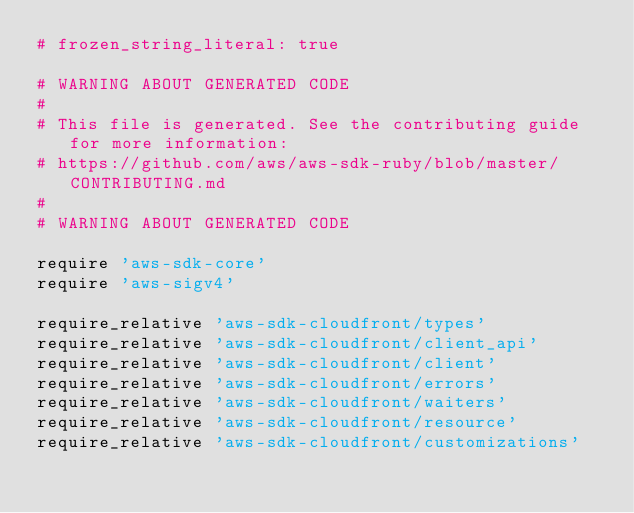Convert code to text. <code><loc_0><loc_0><loc_500><loc_500><_Ruby_># frozen_string_literal: true

# WARNING ABOUT GENERATED CODE
#
# This file is generated. See the contributing guide for more information:
# https://github.com/aws/aws-sdk-ruby/blob/master/CONTRIBUTING.md
#
# WARNING ABOUT GENERATED CODE

require 'aws-sdk-core'
require 'aws-sigv4'

require_relative 'aws-sdk-cloudfront/types'
require_relative 'aws-sdk-cloudfront/client_api'
require_relative 'aws-sdk-cloudfront/client'
require_relative 'aws-sdk-cloudfront/errors'
require_relative 'aws-sdk-cloudfront/waiters'
require_relative 'aws-sdk-cloudfront/resource'
require_relative 'aws-sdk-cloudfront/customizations'
</code> 